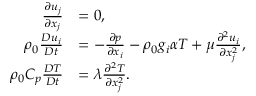Convert formula to latex. <formula><loc_0><loc_0><loc_500><loc_500>\begin{array} { r l } { \frac { \partial u _ { j } } { \partial x _ { j } } } & { = 0 , } \\ { \rho _ { 0 } \frac { D u _ { i } } { D t } } & { = - \frac { \partial p } { \partial x _ { i } } - \rho _ { 0 } g _ { i } \alpha T + \mu \frac { \partial ^ { 2 } u _ { i } } { \partial x _ { j } ^ { 2 } } , } \\ { \rho _ { 0 } C _ { p } \frac { D T } { D t } } & { = \lambda \frac { \partial ^ { 2 } T } { \partial x _ { j } ^ { 2 } } . } \end{array}</formula> 